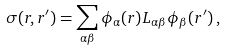Convert formula to latex. <formula><loc_0><loc_0><loc_500><loc_500>\sigma ( { r } , { r } ^ { \prime } ) = \sum _ { \alpha \beta } \phi _ { \alpha } ( { r } ) L _ { \alpha \beta } \phi _ { \beta } ( { r } ^ { \prime } ) \, ,</formula> 